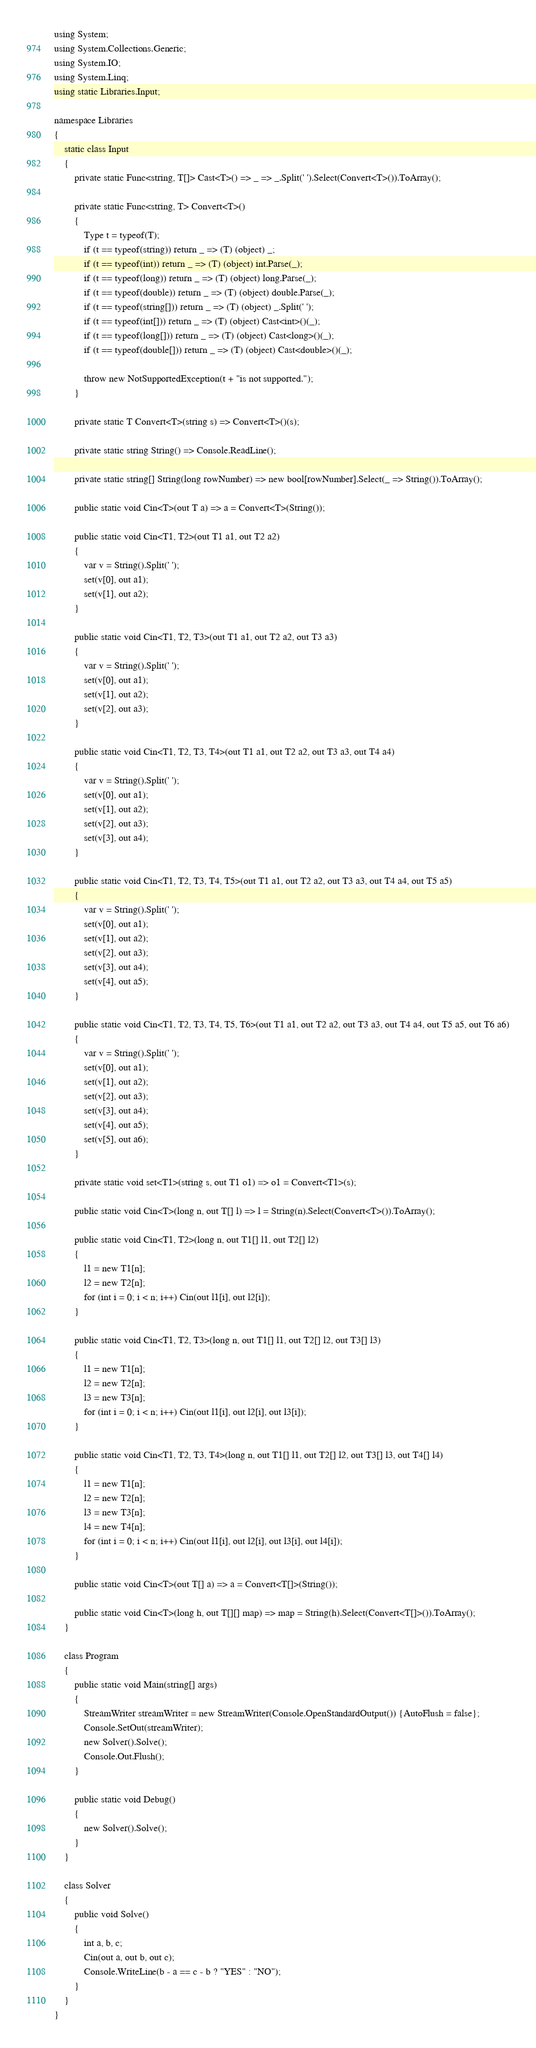<code> <loc_0><loc_0><loc_500><loc_500><_C#_>using System;
using System.Collections.Generic;
using System.IO;
using System.Linq;
using static Libraries.Input;

namespace Libraries
{
    static class Input
    {
        private static Func<string, T[]> Cast<T>() => _ => _.Split(' ').Select(Convert<T>()).ToArray();

        private static Func<string, T> Convert<T>()
        {
            Type t = typeof(T);
            if (t == typeof(string)) return _ => (T) (object) _;
            if (t == typeof(int)) return _ => (T) (object) int.Parse(_);
            if (t == typeof(long)) return _ => (T) (object) long.Parse(_);
            if (t == typeof(double)) return _ => (T) (object) double.Parse(_);
            if (t == typeof(string[])) return _ => (T) (object) _.Split(' ');
            if (t == typeof(int[])) return _ => (T) (object) Cast<int>()(_);
            if (t == typeof(long[])) return _ => (T) (object) Cast<long>()(_);
            if (t == typeof(double[])) return _ => (T) (object) Cast<double>()(_);

            throw new NotSupportedException(t + "is not supported.");
        }

        private static T Convert<T>(string s) => Convert<T>()(s);

        private static string String() => Console.ReadLine();

        private static string[] String(long rowNumber) => new bool[rowNumber].Select(_ => String()).ToArray();

        public static void Cin<T>(out T a) => a = Convert<T>(String());

        public static void Cin<T1, T2>(out T1 a1, out T2 a2)
        {
            var v = String().Split(' ');
            set(v[0], out a1);
            set(v[1], out a2);
        }

        public static void Cin<T1, T2, T3>(out T1 a1, out T2 a2, out T3 a3)
        {
            var v = String().Split(' ');
            set(v[0], out a1);
            set(v[1], out a2);
            set(v[2], out a3);
        }

        public static void Cin<T1, T2, T3, T4>(out T1 a1, out T2 a2, out T3 a3, out T4 a4)
        {
            var v = String().Split(' ');
            set(v[0], out a1);
            set(v[1], out a2);
            set(v[2], out a3);
            set(v[3], out a4);
        }

        public static void Cin<T1, T2, T3, T4, T5>(out T1 a1, out T2 a2, out T3 a3, out T4 a4, out T5 a5)
        {
            var v = String().Split(' ');
            set(v[0], out a1);
            set(v[1], out a2);
            set(v[2], out a3);
            set(v[3], out a4);
            set(v[4], out a5);
        }

        public static void Cin<T1, T2, T3, T4, T5, T6>(out T1 a1, out T2 a2, out T3 a3, out T4 a4, out T5 a5, out T6 a6)
        {
            var v = String().Split(' ');
            set(v[0], out a1);
            set(v[1], out a2);
            set(v[2], out a3);
            set(v[3], out a4);
            set(v[4], out a5);
            set(v[5], out a6);
        }

        private static void set<T1>(string s, out T1 o1) => o1 = Convert<T1>(s);

        public static void Cin<T>(long n, out T[] l) => l = String(n).Select(Convert<T>()).ToArray();

        public static void Cin<T1, T2>(long n, out T1[] l1, out T2[] l2)
        {
            l1 = new T1[n];
            l2 = new T2[n];
            for (int i = 0; i < n; i++) Cin(out l1[i], out l2[i]);
        }

        public static void Cin<T1, T2, T3>(long n, out T1[] l1, out T2[] l2, out T3[] l3)
        {
            l1 = new T1[n];
            l2 = new T2[n];
            l3 = new T3[n];
            for (int i = 0; i < n; i++) Cin(out l1[i], out l2[i], out l3[i]);
        }

        public static void Cin<T1, T2, T3, T4>(long n, out T1[] l1, out T2[] l2, out T3[] l3, out T4[] l4)
        {
            l1 = new T1[n];
            l2 = new T2[n];
            l3 = new T3[n];
            l4 = new T4[n];
            for (int i = 0; i < n; i++) Cin(out l1[i], out l2[i], out l3[i], out l4[i]);
        }

        public static void Cin<T>(out T[] a) => a = Convert<T[]>(String());

        public static void Cin<T>(long h, out T[][] map) => map = String(h).Select(Convert<T[]>()).ToArray();
    }

    class Program
    {
        public static void Main(string[] args)
        {
            StreamWriter streamWriter = new StreamWriter(Console.OpenStandardOutput()) {AutoFlush = false};
            Console.SetOut(streamWriter);
            new Solver().Solve();
            Console.Out.Flush();
        }

        public static void Debug()
        {
            new Solver().Solve();
        }
    }

    class Solver
    {
        public void Solve()
        {
            int a, b, c;
            Cin(out a, out b, out c);
            Console.WriteLine(b - a == c - b ? "YES" : "NO");
        }
    }
}</code> 